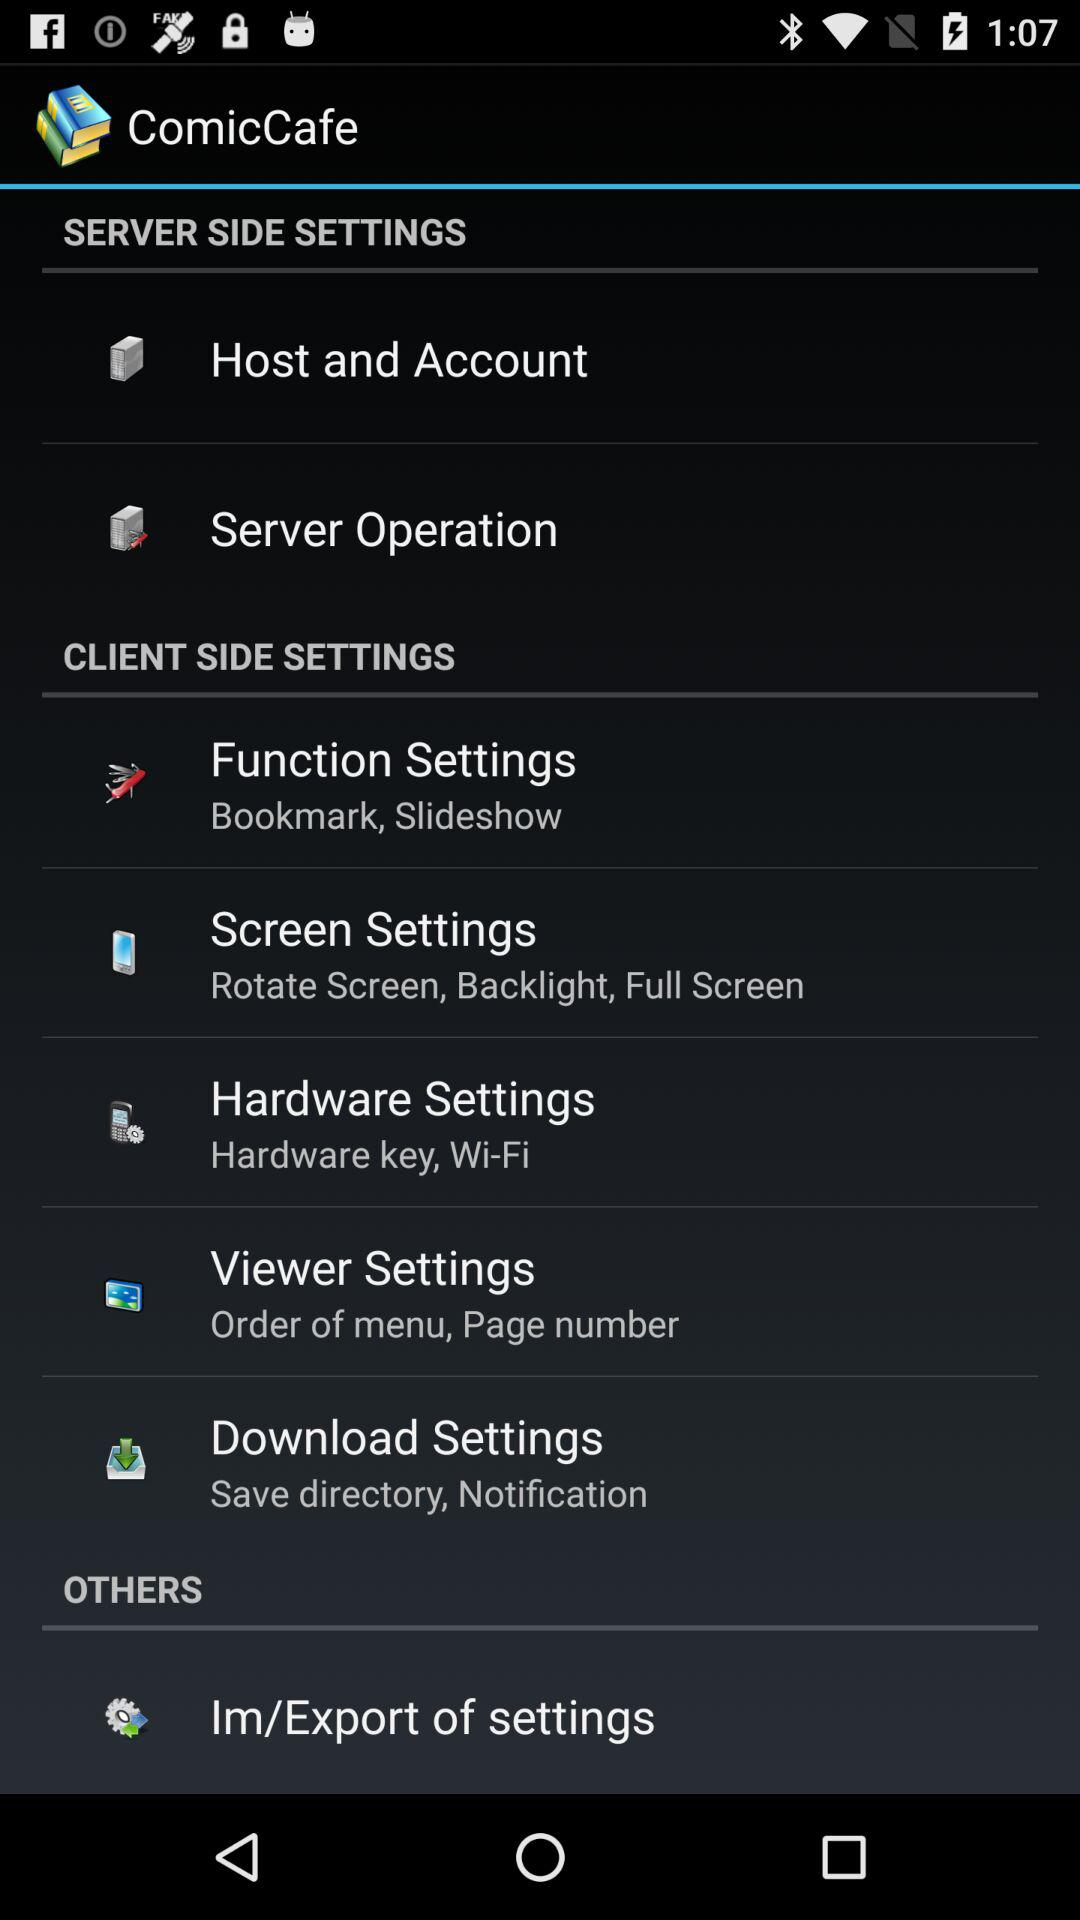What is the name of the application? The name of the application is "ComicCafe". 